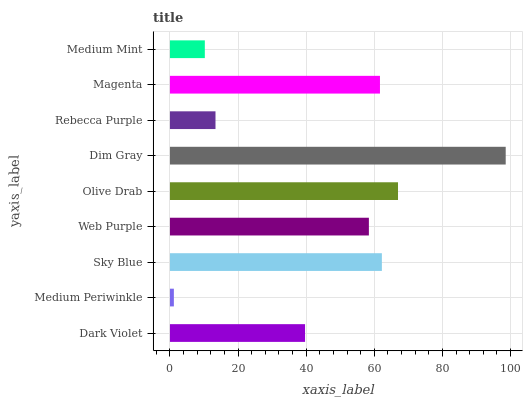Is Medium Periwinkle the minimum?
Answer yes or no. Yes. Is Dim Gray the maximum?
Answer yes or no. Yes. Is Sky Blue the minimum?
Answer yes or no. No. Is Sky Blue the maximum?
Answer yes or no. No. Is Sky Blue greater than Medium Periwinkle?
Answer yes or no. Yes. Is Medium Periwinkle less than Sky Blue?
Answer yes or no. Yes. Is Medium Periwinkle greater than Sky Blue?
Answer yes or no. No. Is Sky Blue less than Medium Periwinkle?
Answer yes or no. No. Is Web Purple the high median?
Answer yes or no. Yes. Is Web Purple the low median?
Answer yes or no. Yes. Is Medium Periwinkle the high median?
Answer yes or no. No. Is Medium Mint the low median?
Answer yes or no. No. 